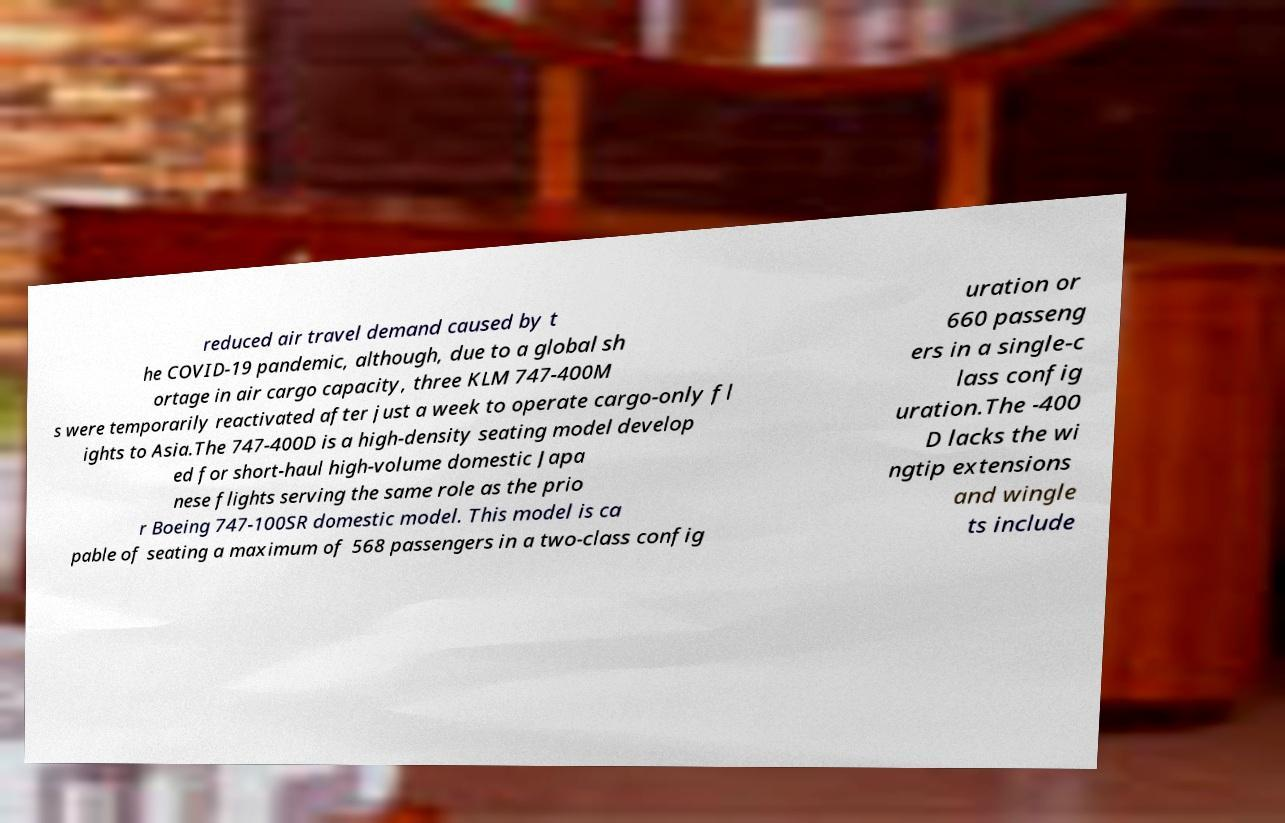Could you assist in decoding the text presented in this image and type it out clearly? reduced air travel demand caused by t he COVID-19 pandemic, although, due to a global sh ortage in air cargo capacity, three KLM 747-400M s were temporarily reactivated after just a week to operate cargo-only fl ights to Asia.The 747-400D is a high-density seating model develop ed for short-haul high-volume domestic Japa nese flights serving the same role as the prio r Boeing 747-100SR domestic model. This model is ca pable of seating a maximum of 568 passengers in a two-class config uration or 660 passeng ers in a single-c lass config uration.The -400 D lacks the wi ngtip extensions and wingle ts include 